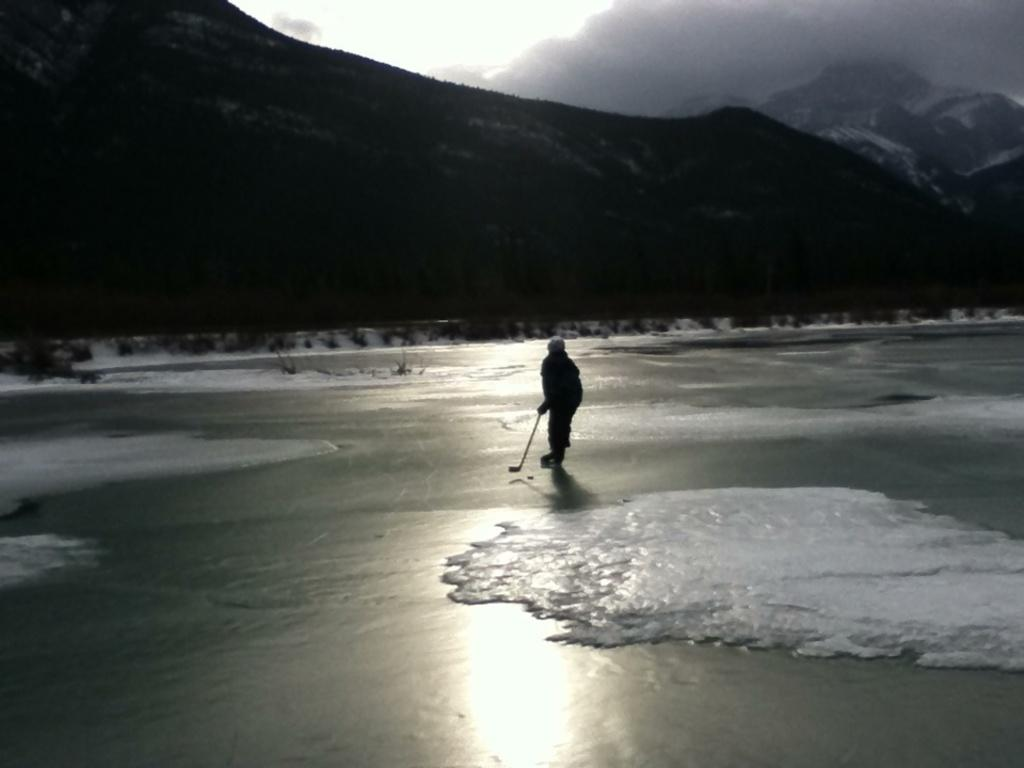What is the person in the image doing? The person is riding a snowboard on an ice surface. What is the person holding while snowboarding? The person is holding a stick. What can be seen in the background of the image? There are mountains in the background of the image. What is visible in the sky in the image? There are clouds in the sky. What type of stove can be seen in the image? There is no stove present in the image. What trade is the person in the image practicing? The image does not depict any specific trade or occupation. 